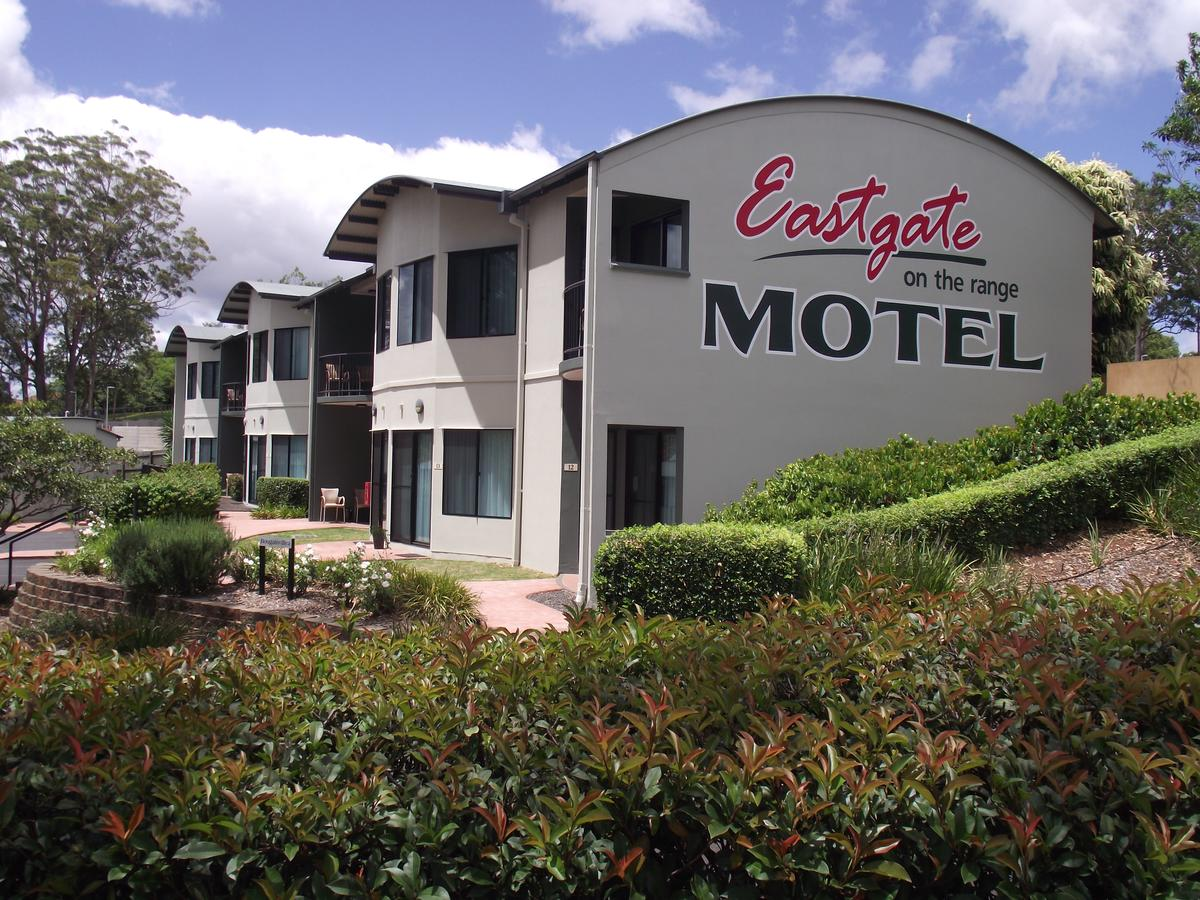Don't forget these rules:
 
1. **Be Direct and Concise**: Provide straightforward descriptions without adding interpretative or speculative elements.
2. **Use Segmented Details**: Break down details about different elements of an image into distinct sentences, focusing on one aspect at a time.
3. **Maintain a Descriptive Focus**: Prioritize purely visible elements of the image, avoiding conclusions or inferences.
4. **Follow a Logical Structure**: Begin with the central figure or subject and expand outward, detailing its appearance before addressing the surrounding setting.
5. **Avoid Juxtaposition**: Do not use comparison or contrast language; keep the description purely factual.
6. **Incorporate Specificity**: Mention age, gender, race, and specific brands or notable features when present, and clearly identify the medium if it's discernible. 
 
When writing descriptions, prioritize clarity and direct observation over embellishment or interpretation.
 
Write a detailed description of this image, do not forget about the texts on it if they exist. Also, do not forget to mention the type / style of the image. No bullet points. The image shows a two-story motel with a gray exterior and dark roofing. The building has multiple doors and windows, some featuring balconies with railings. A prominent sign on the building reads "Eastgate on the range MOTEL" in large, red and gray lettering. In front of the building, there is a landscaped area with a variety of shrubs and plants, as well as a brick pathway leading to the entrance. The sky is partly cloudy, and a few trees can be seen in the background. The overall style of the image is a clear, daytime photograph with a focus on the motel's facade and signage. 